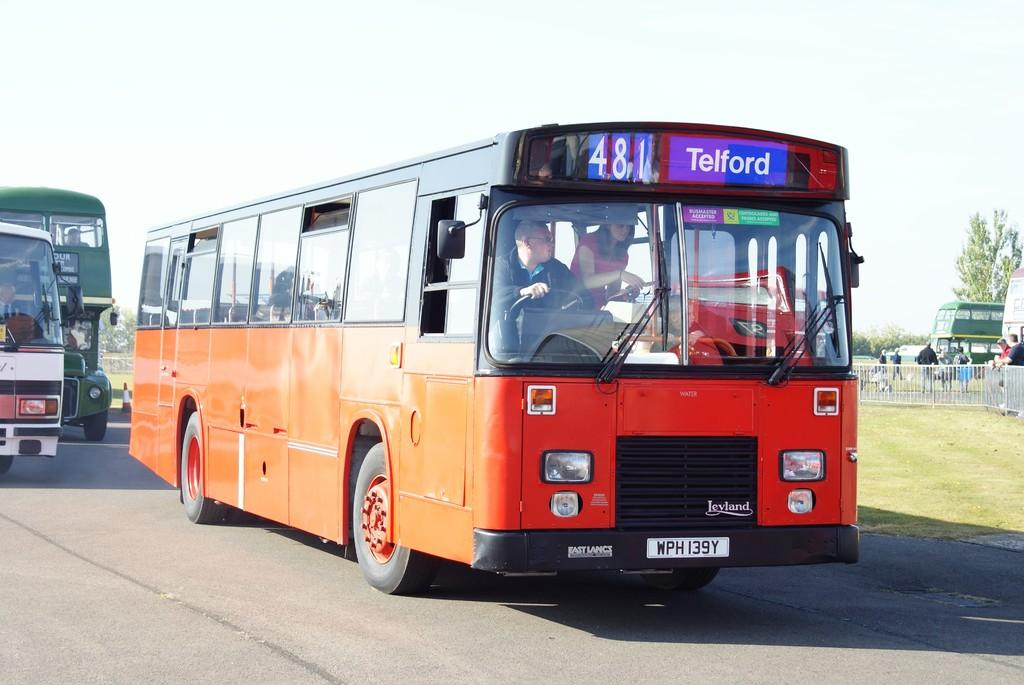<image>
Summarize the visual content of the image. An orange bus on the road is heading to Telford. 